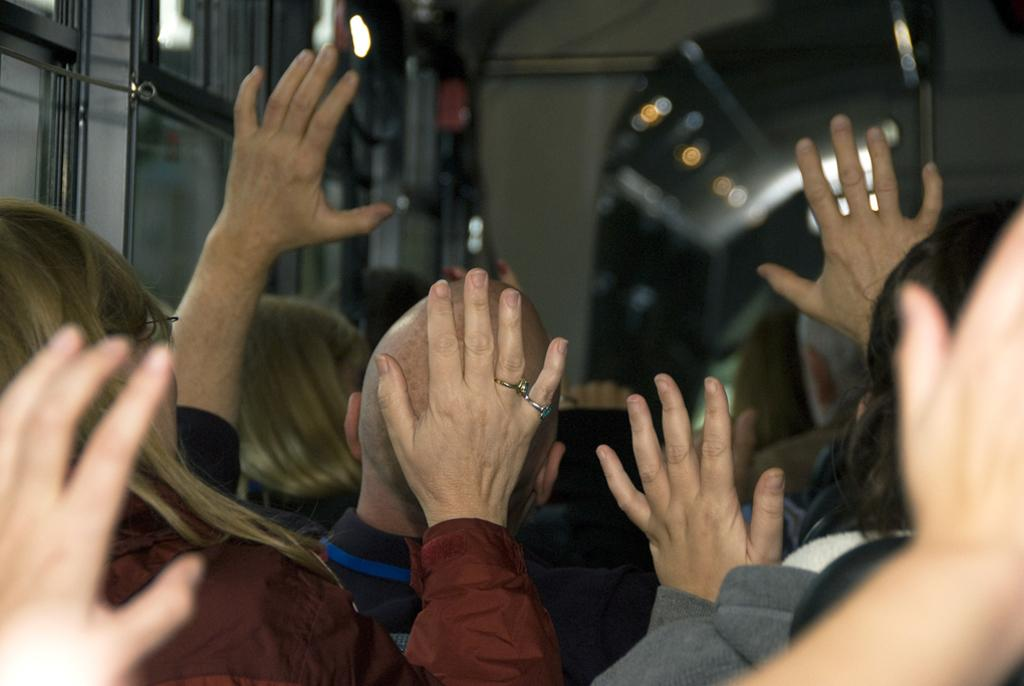How many people are in the image? There is a group of people standing in the image, but the exact number cannot be determined from the provided facts. What can be observed about the background of the image? The background of the image appears blurry. What type of plant is growing on the island in the image? There is no island or plant present in the image; it only features a group of people and a blurry background. 